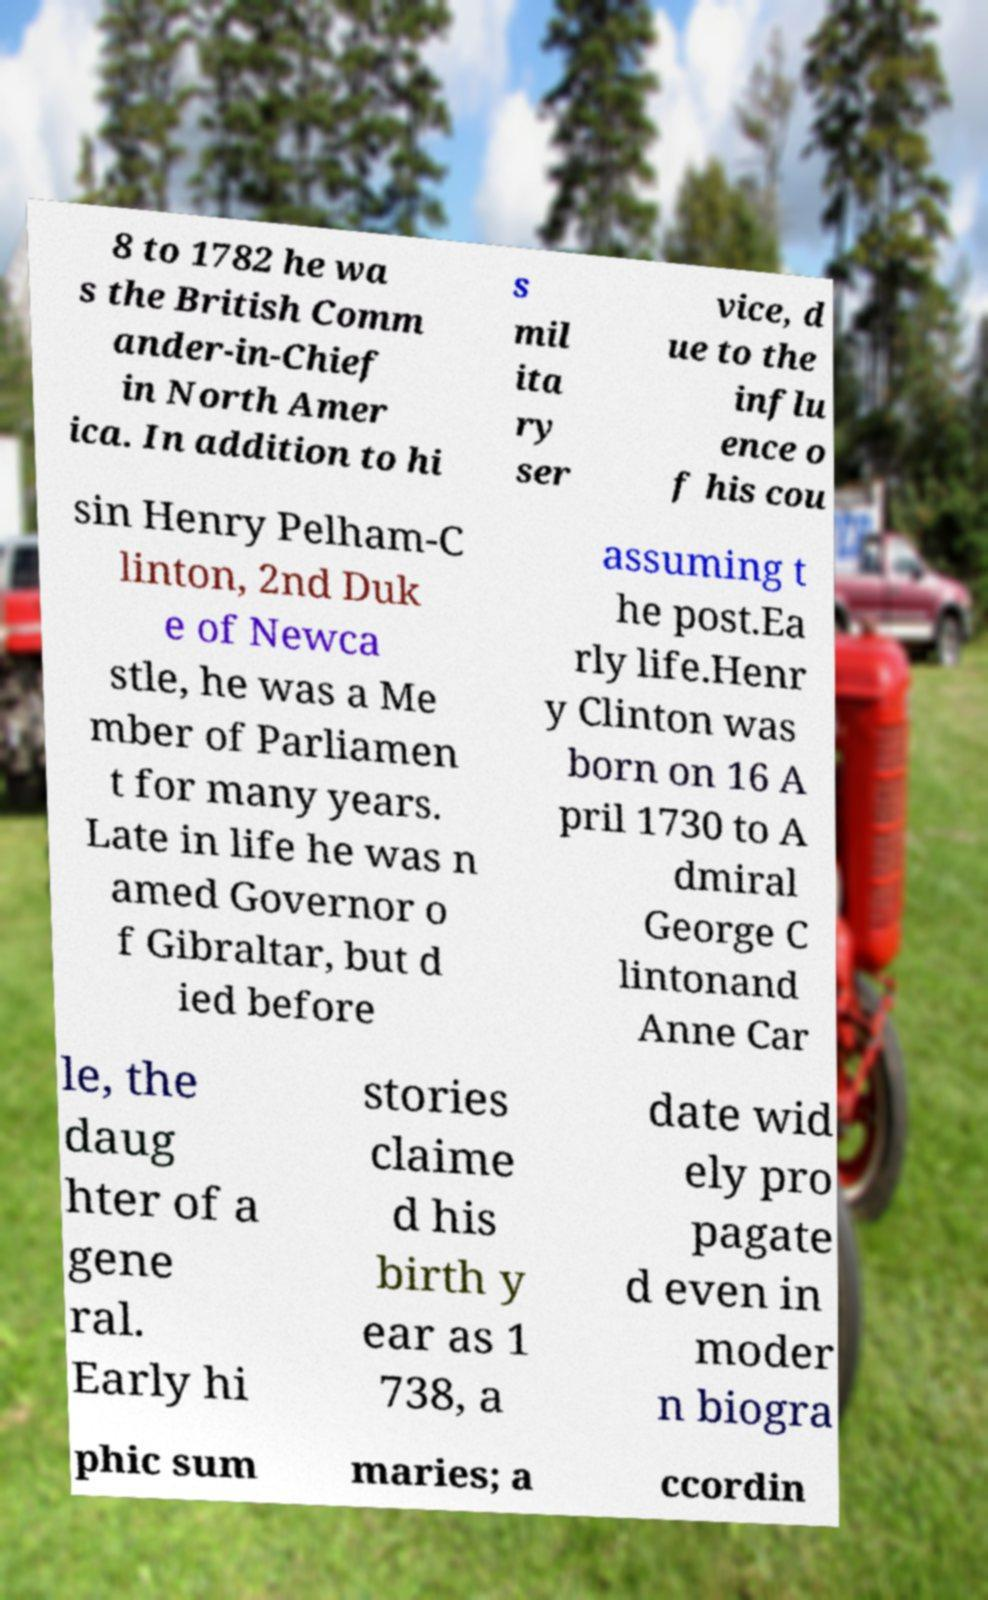Please identify and transcribe the text found in this image. 8 to 1782 he wa s the British Comm ander-in-Chief in North Amer ica. In addition to hi s mil ita ry ser vice, d ue to the influ ence o f his cou sin Henry Pelham-C linton, 2nd Duk e of Newca stle, he was a Me mber of Parliamen t for many years. Late in life he was n amed Governor o f Gibraltar, but d ied before assuming t he post.Ea rly life.Henr y Clinton was born on 16 A pril 1730 to A dmiral George C lintonand Anne Car le, the daug hter of a gene ral. Early hi stories claime d his birth y ear as 1 738, a date wid ely pro pagate d even in moder n biogra phic sum maries; a ccordin 